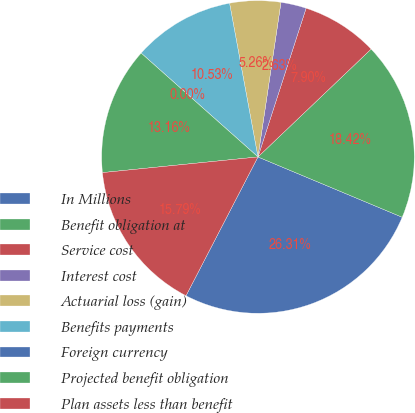Convert chart. <chart><loc_0><loc_0><loc_500><loc_500><pie_chart><fcel>In Millions<fcel>Benefit obligation at<fcel>Service cost<fcel>Interest cost<fcel>Actuarial loss (gain)<fcel>Benefits payments<fcel>Foreign currency<fcel>Projected benefit obligation<fcel>Plan assets less than benefit<nl><fcel>26.31%<fcel>18.42%<fcel>7.9%<fcel>2.63%<fcel>5.26%<fcel>10.53%<fcel>0.0%<fcel>13.16%<fcel>15.79%<nl></chart> 